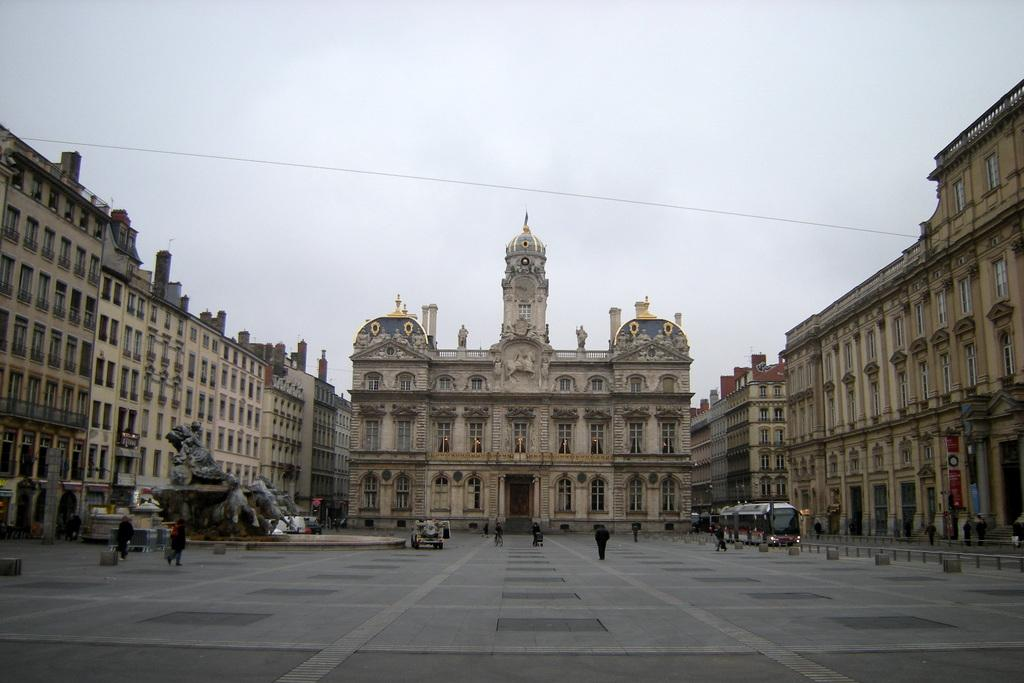What type of structures can be seen in the image? There are buildings in the image. Are there any living beings in the image? Yes, there are people in the image. What is located in front of the buildings? There are statues in front of the buildings. What else can be seen in the image besides buildings and people? Vehicles and hoardings are visible in the image. What type of cheese is being used to build the statues in the image? There is no cheese present in the image; the statues are not made of cheese. 